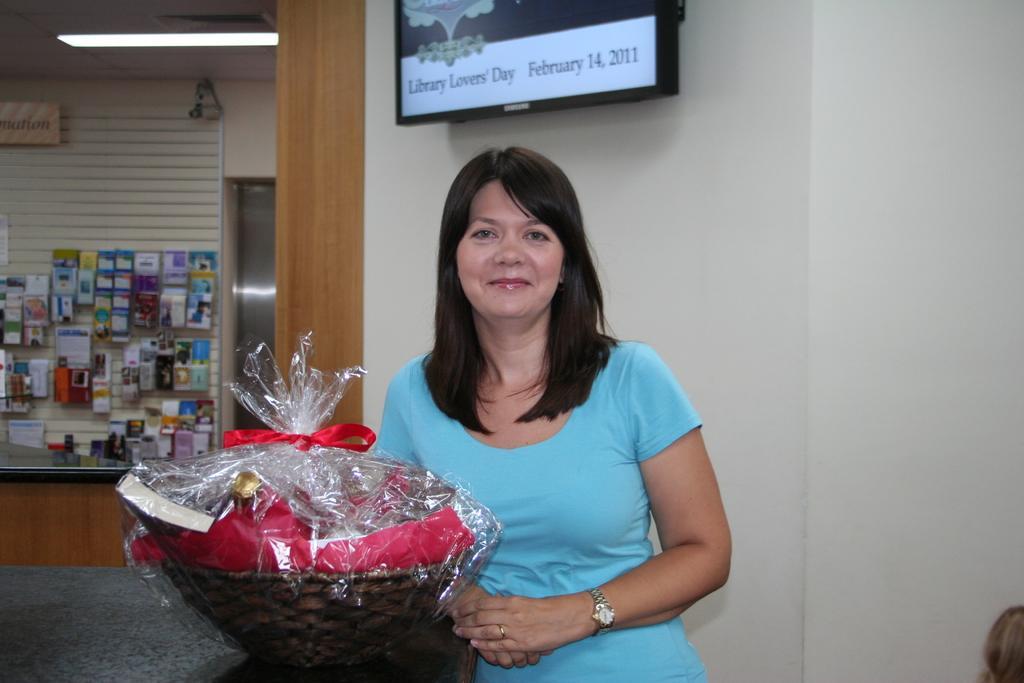How would you summarize this image in a sentence or two? As we can see in the image there is a woman wearing sky blue color dress. There is a wall, basket, table, screen, light, banner and a wall. In the background there are covers. 